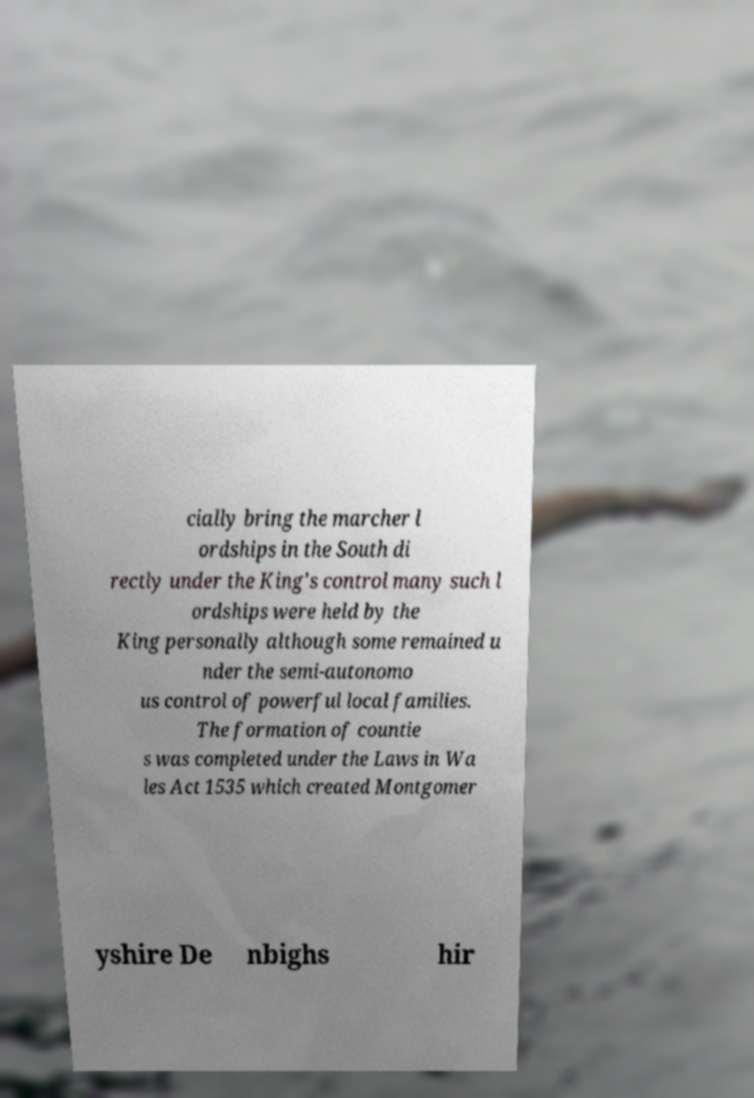Please read and relay the text visible in this image. What does it say? cially bring the marcher l ordships in the South di rectly under the King's control many such l ordships were held by the King personally although some remained u nder the semi-autonomo us control of powerful local families. The formation of countie s was completed under the Laws in Wa les Act 1535 which created Montgomer yshire De nbighs hir 